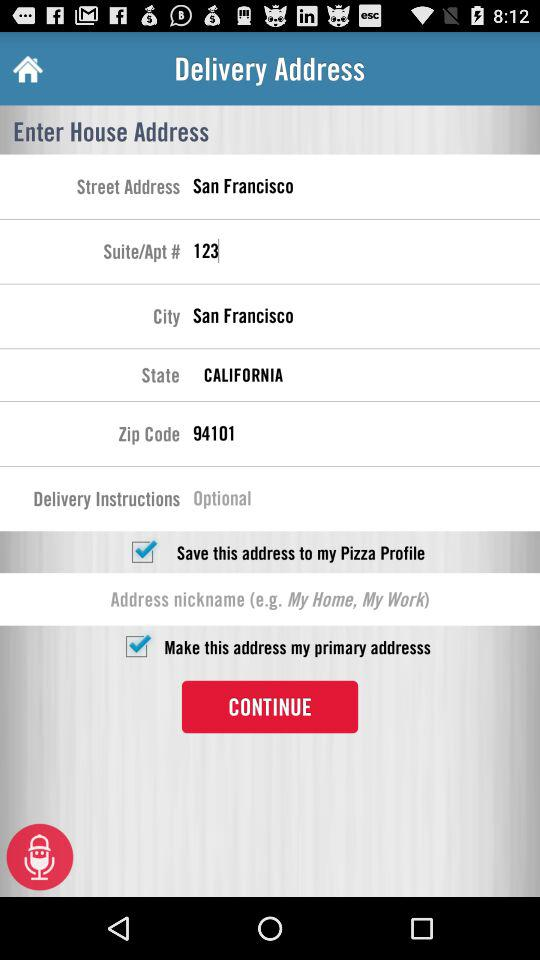What is the zip code? The zip code is 94101. 